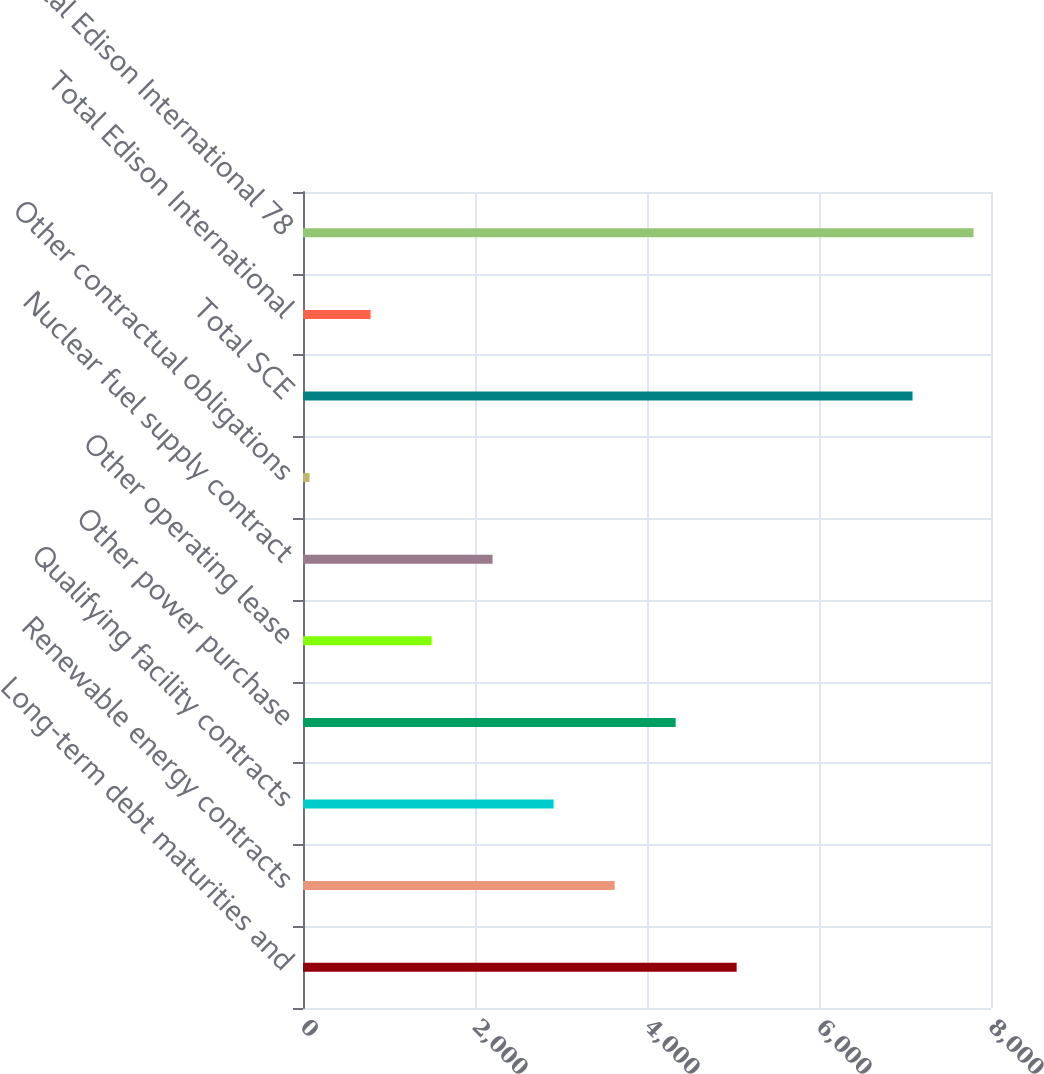Convert chart to OTSL. <chart><loc_0><loc_0><loc_500><loc_500><bar_chart><fcel>Long-term debt maturities and<fcel>Renewable energy contracts<fcel>Qualifying facility contracts<fcel>Other power purchase<fcel>Other operating lease<fcel>Nuclear fuel supply contract<fcel>Other contractual obligations<fcel>Total SCE<fcel>Total Edison International<fcel>Total Edison International 78<nl><fcel>5042.5<fcel>3623.5<fcel>2914<fcel>4333<fcel>1495<fcel>2204.5<fcel>76<fcel>7087<fcel>785.5<fcel>7796.5<nl></chart> 